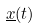<formula> <loc_0><loc_0><loc_500><loc_500>\underline { x } ( t )</formula> 